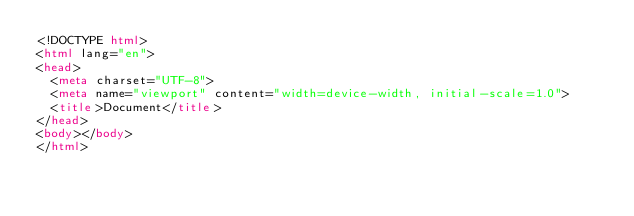<code> <loc_0><loc_0><loc_500><loc_500><_HTML_><!DOCTYPE html>
<html lang="en">
<head>
  <meta charset="UTF-8">
  <meta name="viewport" content="width=device-width, initial-scale=1.0">
  <title>Document</title>
</head>
<body></body>
</html>
</code> 